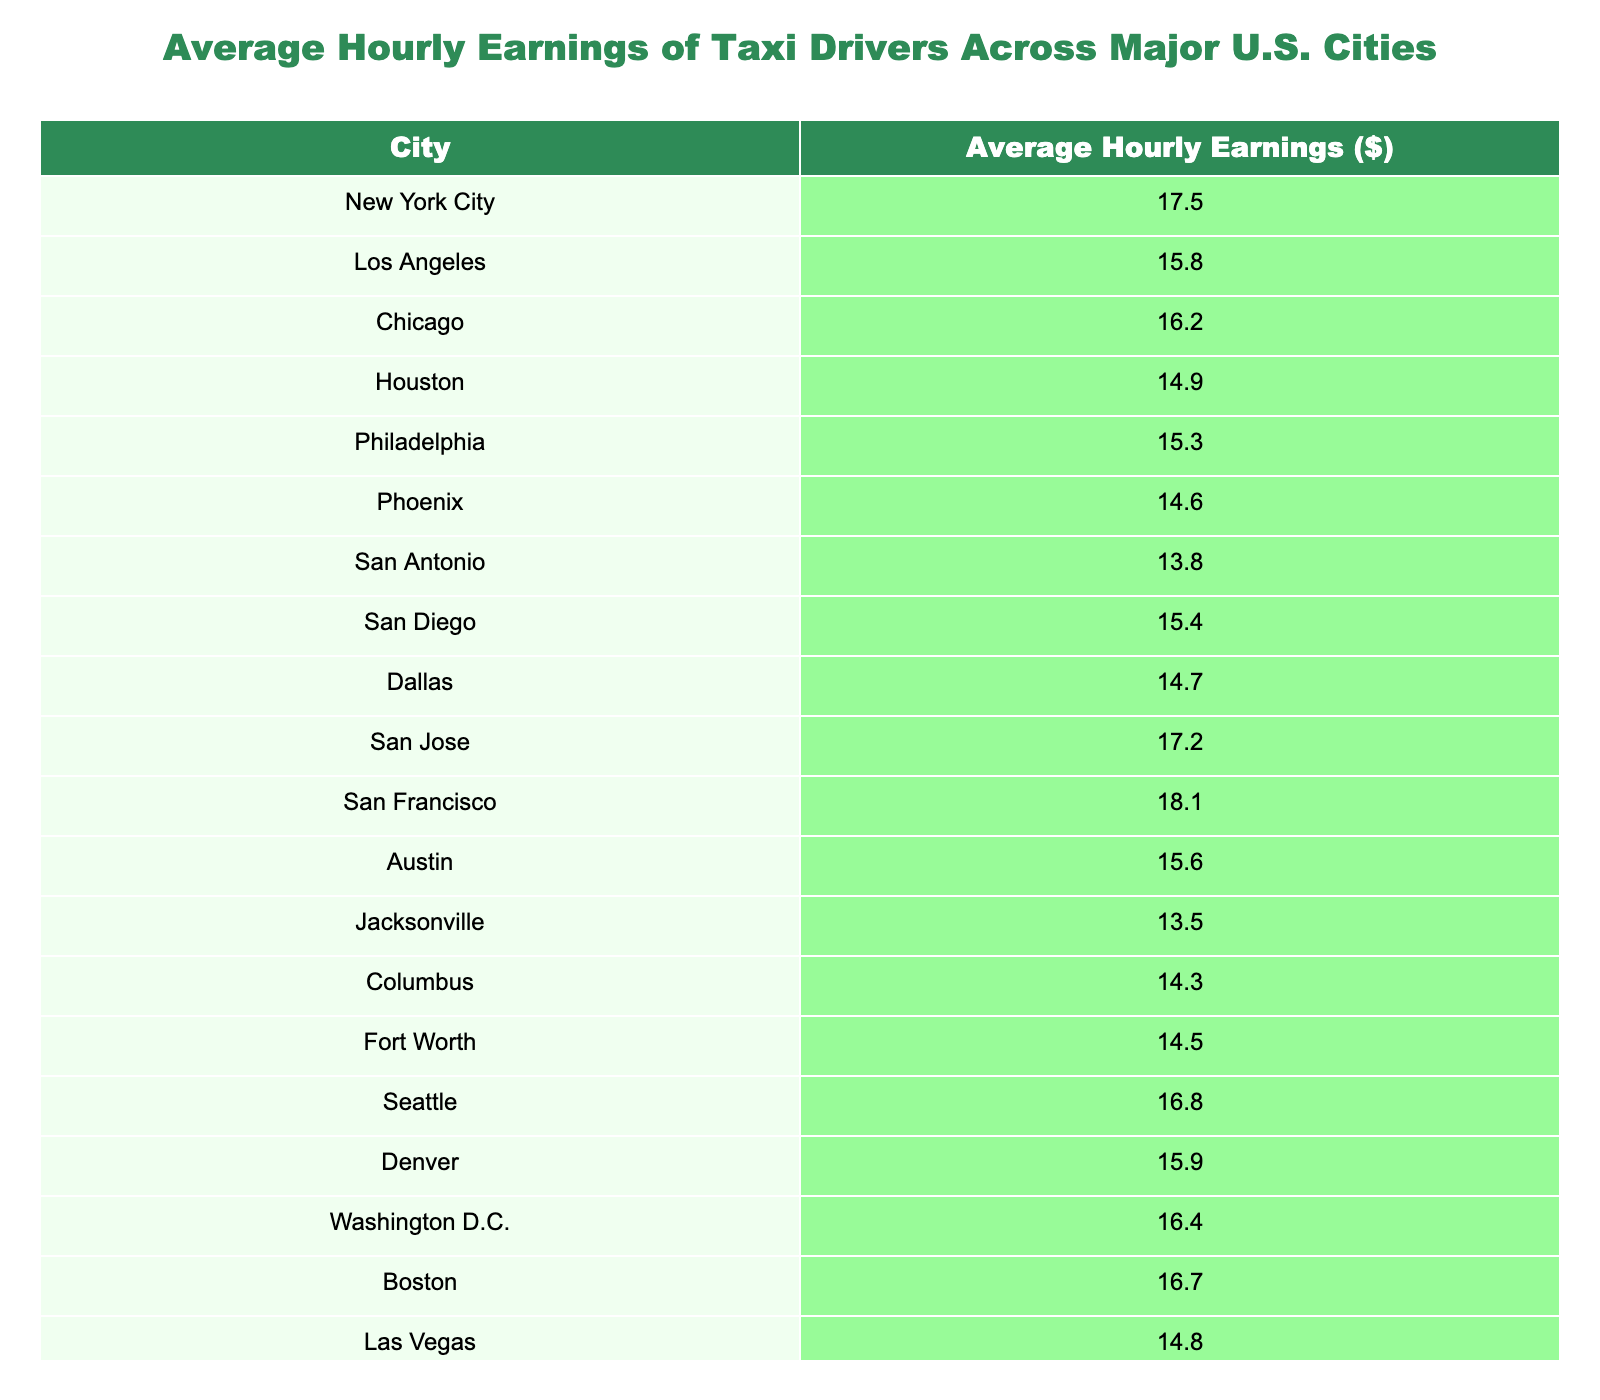What is the average hourly earnings of taxi drivers in New York City? According to the table, the average hourly earnings for taxi drivers in New York City is $17.50.
Answer: $17.50 Which city has the highest average hourly earnings for taxi drivers? The table shows that San Francisco has the highest average hourly earnings at $18.10.
Answer: San Francisco What is the difference in average hourly earnings between Los Angeles and Houston? The average hourly earnings for Los Angeles is $15.80 and for Houston is $14.90. The difference is $15.80 - $14.90 = $0.90.
Answer: $0.90 Is the average hourly earnings for taxi drivers in Chicago greater than the average in Philadelphia? The average hourly earnings for Chicago is $16.20 and for Philadelphia is $15.30. Since $16.20 is greater than $15.30, the statement is true.
Answer: Yes What is the average hourly earnings of taxi drivers for the cities of Austin, Dallas, and San Antonio? The average hourly earnings for Austin is $15.60, Dallas is $14.70, and San Antonio is $13.80. Summing these values gives $15.60 + $14.70 + $13.80 = $44.10. To find the average: $44.10 / 3 = $14.70.
Answer: $14.70 Which two cities have the closest average hourly earnings? By examining the values, we see that San Antonio ($13.80) and Jacksonville ($13.50) have a difference of only $0.30. All other cities have greater differences between their average earnings.
Answer: San Antonio and Jacksonville What is the median average hourly earnings for taxi drivers across all cities listed in the table? The average hourly earnings, when sorted, are: $13.50, $13.80, $14.30, $14.50, $14.60, $14.70, $14.80, $15.30, $15.40, $15.60, $15.80, $15.90, $16.20, $16.40, $16.70, $16.80, $17.20, $17.50, $18.10. Since there are 20 values, the median will be the average of the 10th and 11th values: ($15.60 + $15.80) / 2 = $15.70.
Answer: $15.70 How much do taxi drivers in Washington D.C. earn on average compared to those in Las Vegas? The average hourly earnings for taxi drivers in Washington D.C. is $16.40 and in Las Vegas it is $14.80. The comparison shows that Washington D.C. taxi drivers earn $1.60 more than those in Las Vegas, since $16.40 - $14.80 = $1.60.
Answer: Washington D.C. earns $1.60 more What percentage of cities have average hourly earnings above $16.00? To determine the percentage, count the number of cities with earnings above $16.00: San Francisco, San Jose, Seattle, New York City, and Washington D.C. amounts to 5 cities out of 20. Thus, (5/20) * 100 = 25%.
Answer: 25% 